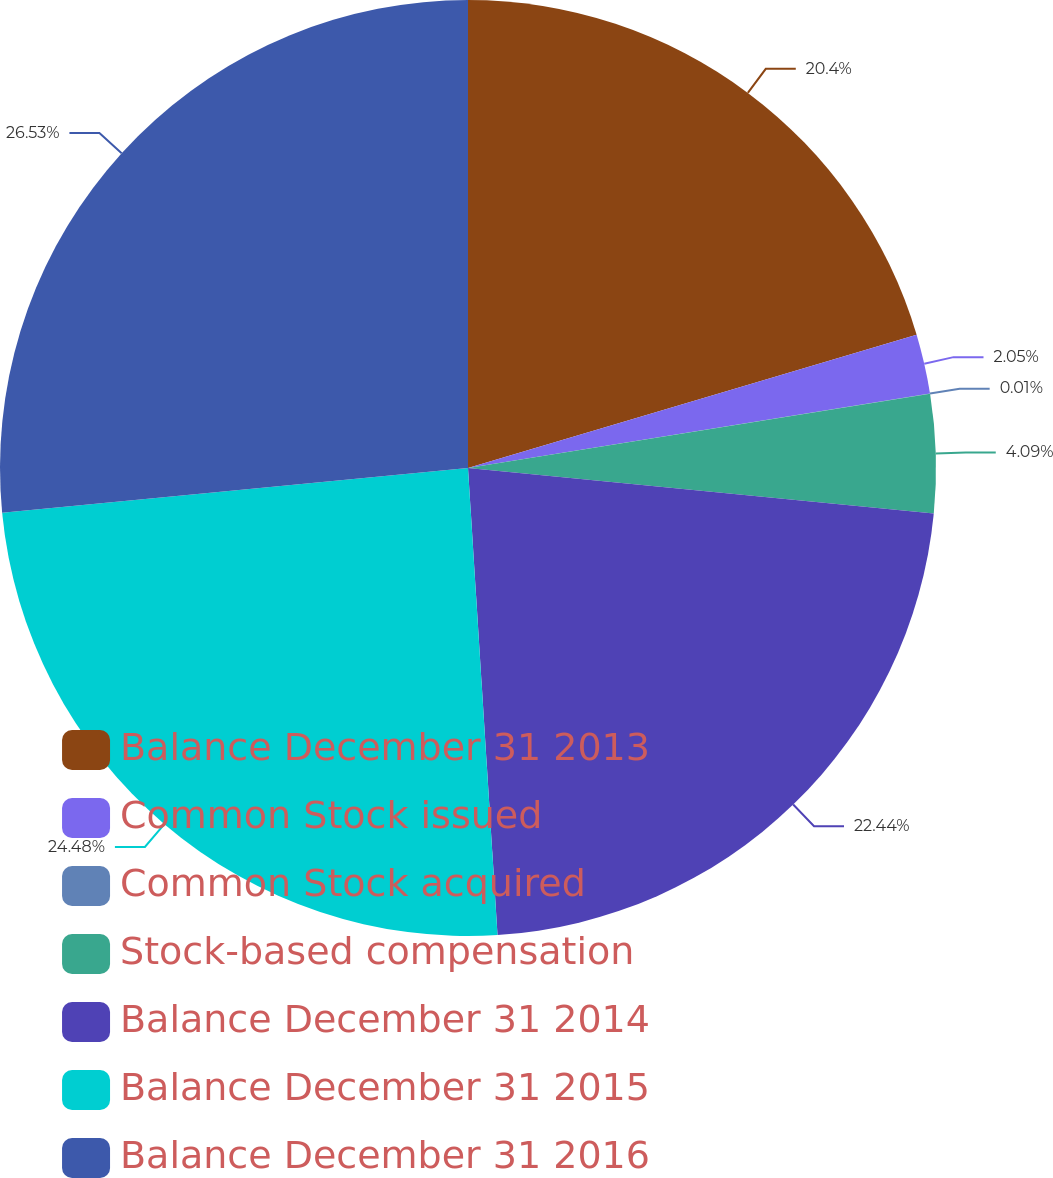<chart> <loc_0><loc_0><loc_500><loc_500><pie_chart><fcel>Balance December 31 2013<fcel>Common Stock issued<fcel>Common Stock acquired<fcel>Stock-based compensation<fcel>Balance December 31 2014<fcel>Balance December 31 2015<fcel>Balance December 31 2016<nl><fcel>20.4%<fcel>2.05%<fcel>0.01%<fcel>4.09%<fcel>22.44%<fcel>24.48%<fcel>26.52%<nl></chart> 